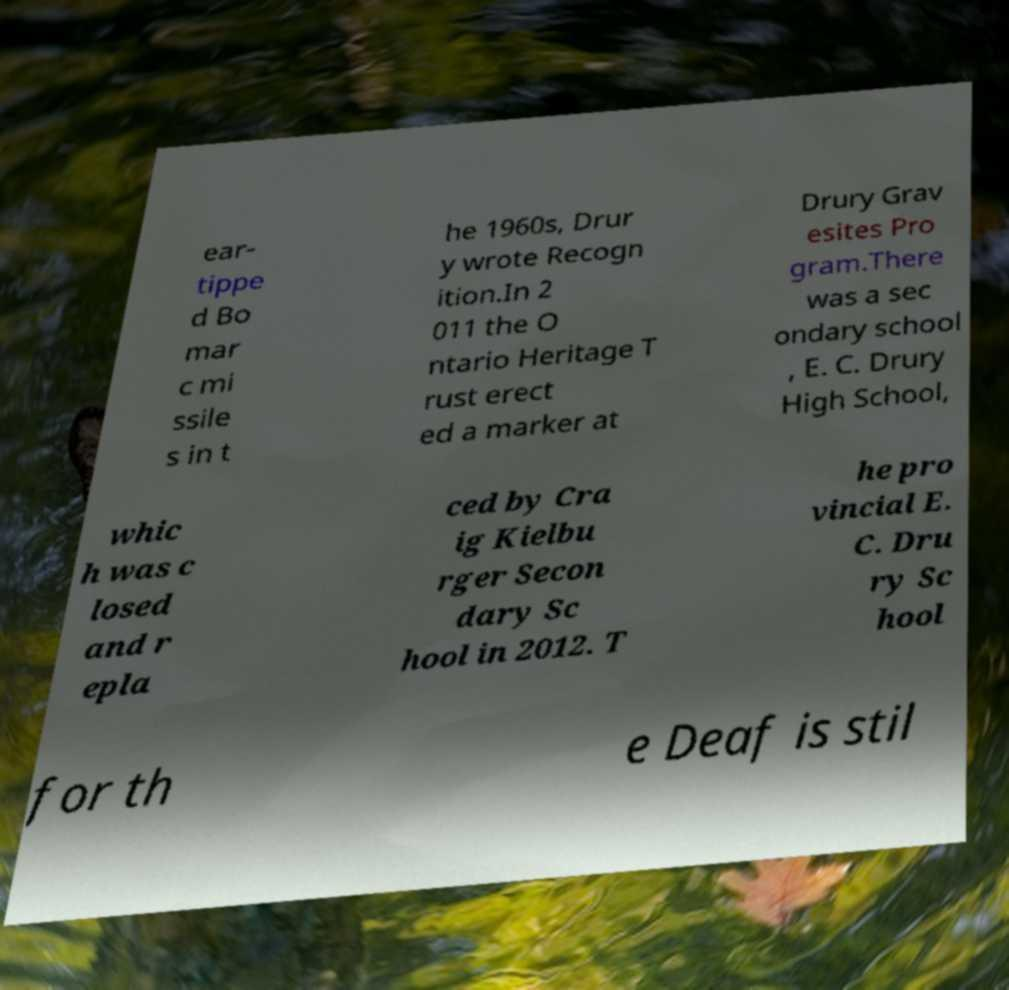Please read and relay the text visible in this image. What does it say? ear- tippe d Bo mar c mi ssile s in t he 1960s, Drur y wrote Recogn ition.In 2 011 the O ntario Heritage T rust erect ed a marker at Drury Grav esites Pro gram.There was a sec ondary school , E. C. Drury High School, whic h was c losed and r epla ced by Cra ig Kielbu rger Secon dary Sc hool in 2012. T he pro vincial E. C. Dru ry Sc hool for th e Deaf is stil 